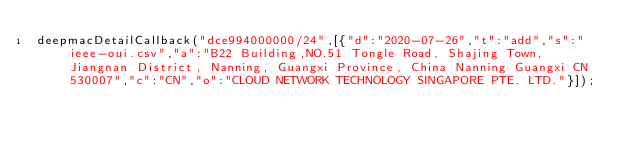<code> <loc_0><loc_0><loc_500><loc_500><_JavaScript_>deepmacDetailCallback("dce994000000/24",[{"d":"2020-07-26","t":"add","s":"ieee-oui.csv","a":"B22 Building,NO.51 Tongle Road, Shajing Town, Jiangnan District, Nanning, Guangxi Province, China Nanning Guangxi CN 530007","c":"CN","o":"CLOUD NETWORK TECHNOLOGY SINGAPORE PTE. LTD."}]);
</code> 